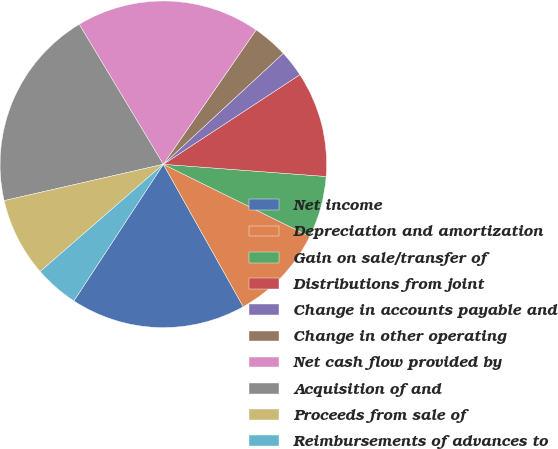Convert chart to OTSL. <chart><loc_0><loc_0><loc_500><loc_500><pie_chart><fcel>Net income<fcel>Depreciation and amortization<fcel>Gain on sale/transfer of<fcel>Distributions from joint<fcel>Change in accounts payable and<fcel>Change in other operating<fcel>Net cash flow provided by<fcel>Acquisition of and<fcel>Proceeds from sale of<fcel>Reimbursements of advances to<nl><fcel>17.36%<fcel>9.57%<fcel>6.1%<fcel>10.43%<fcel>2.64%<fcel>3.5%<fcel>18.23%<fcel>19.96%<fcel>7.83%<fcel>4.37%<nl></chart> 